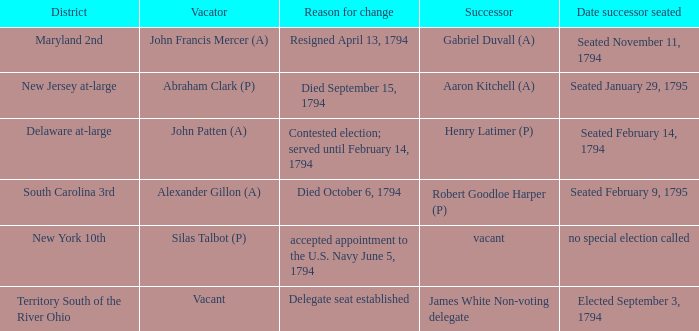Name the date successor seated for contested election; served until february 14, 1794 Seated February 14, 1794. 